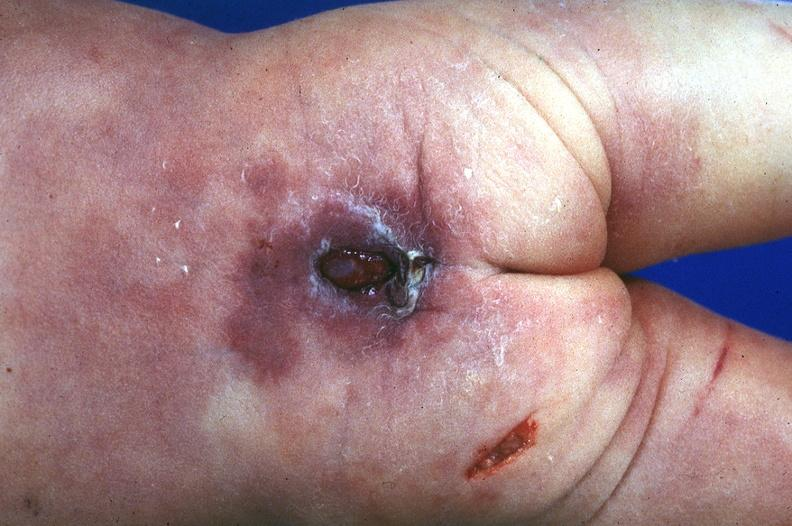what does this image show?
Answer the question using a single word or phrase. Neural tube defect 